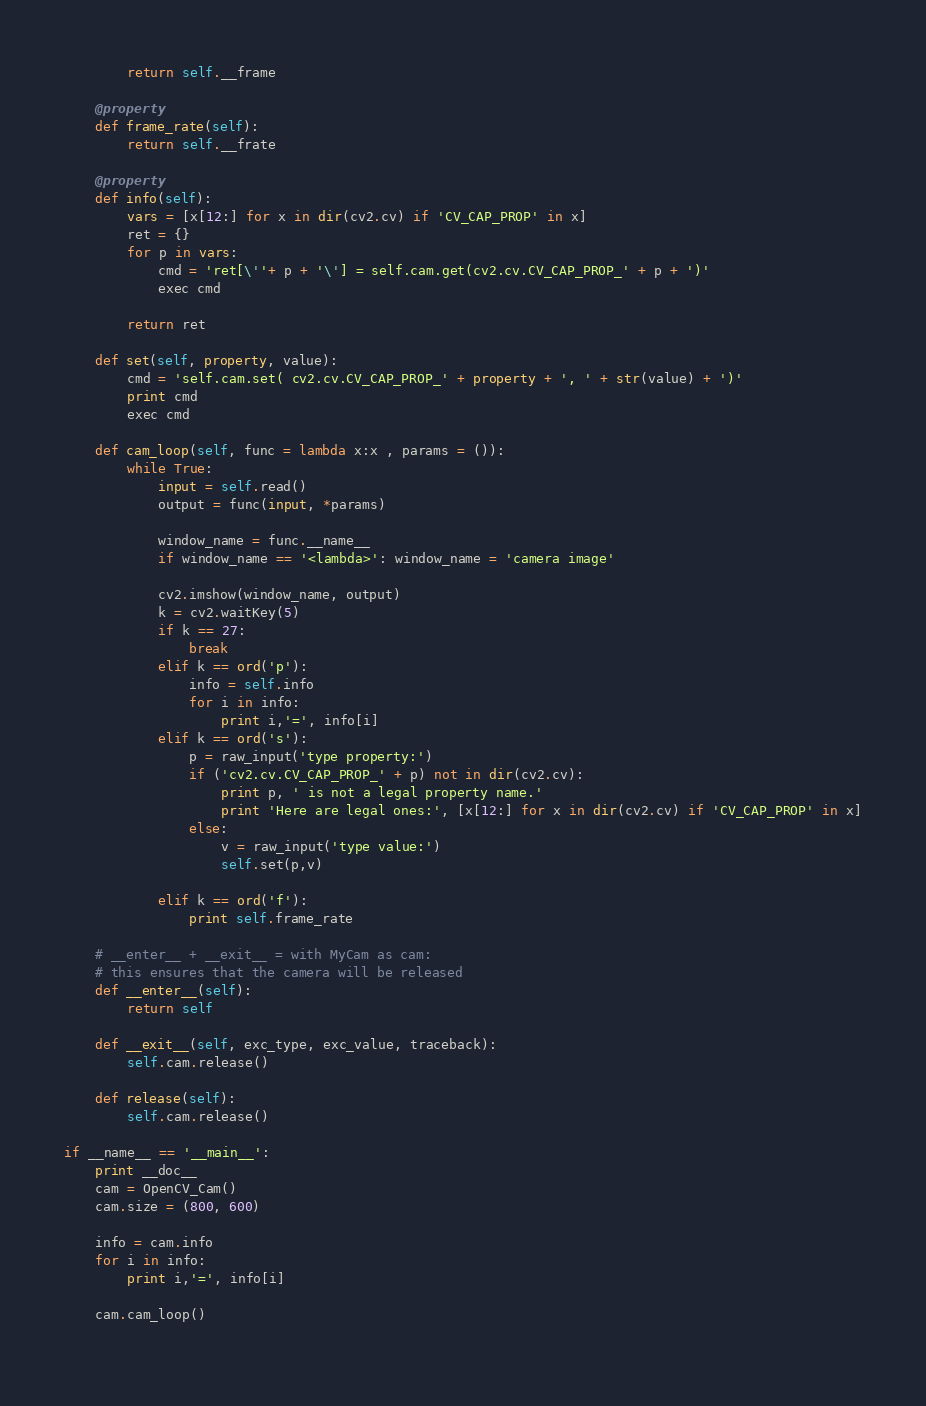<code> <loc_0><loc_0><loc_500><loc_500><_Python_>        return self.__frame

    @property
    def frame_rate(self):
        return self.__frate
        
    @property
    def info(self):
        vars = [x[12:] for x in dir(cv2.cv) if 'CV_CAP_PROP' in x]
        ret = {}
        for p in vars:
            cmd = 'ret[\''+ p + '\'] = self.cam.get(cv2.cv.CV_CAP_PROP_' + p + ')'
            exec cmd
            
        return ret

    def set(self, property, value):
        cmd = 'self.cam.set( cv2.cv.CV_CAP_PROP_' + property + ', ' + str(value) + ')'
        print cmd
        exec cmd
    
    def cam_loop(self, func = lambda x:x , params = ()):
        while True:
            input = self.read()
            output = func(input, *params)
            
            window_name = func.__name__
            if window_name == '<lambda>': window_name = 'camera image'
            
            cv2.imshow(window_name, output)
            k = cv2.waitKey(5)
            if k == 27:
                break
            elif k == ord('p'):
                info = self.info
                for i in info:
                    print i,'=', info[i]
            elif k == ord('s'):
                p = raw_input('type property:')
                if ('cv2.cv.CV_CAP_PROP_' + p) not in dir(cv2.cv):
                    print p, ' is not a legal property name.'
                    print 'Here are legal ones:', [x[12:] for x in dir(cv2.cv) if 'CV_CAP_PROP' in x]
                else:
                    v = raw_input('type value:')
                    self.set(p,v)
                        
            elif k == ord('f'):
                print self.frame_rate
    
    # __enter__ + __exit__ = with MyCam as cam:
    # this ensures that the camera will be released
    def __enter__(self):
        return self
    
    def __exit__(self, exc_type, exc_value, traceback):
        self.cam.release()
    
    def release(self):
        self.cam.release()
    
if __name__ == '__main__':
    print __doc__
    cam = OpenCV_Cam()
    cam.size = (800, 600)

    info = cam.info
    for i in info:
        print i,'=', info[i]
    
    cam.cam_loop()
        </code> 